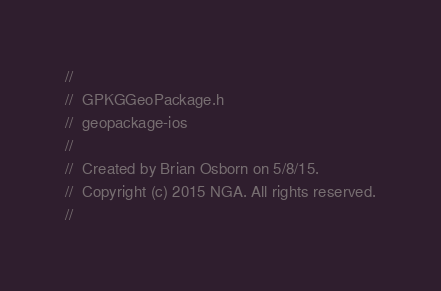<code> <loc_0><loc_0><loc_500><loc_500><_C_>//
//  GPKGGeoPackage.h
//  geopackage-ios
//
//  Created by Brian Osborn on 5/8/15.
//  Copyright (c) 2015 NGA. All rights reserved.
//
</code> 